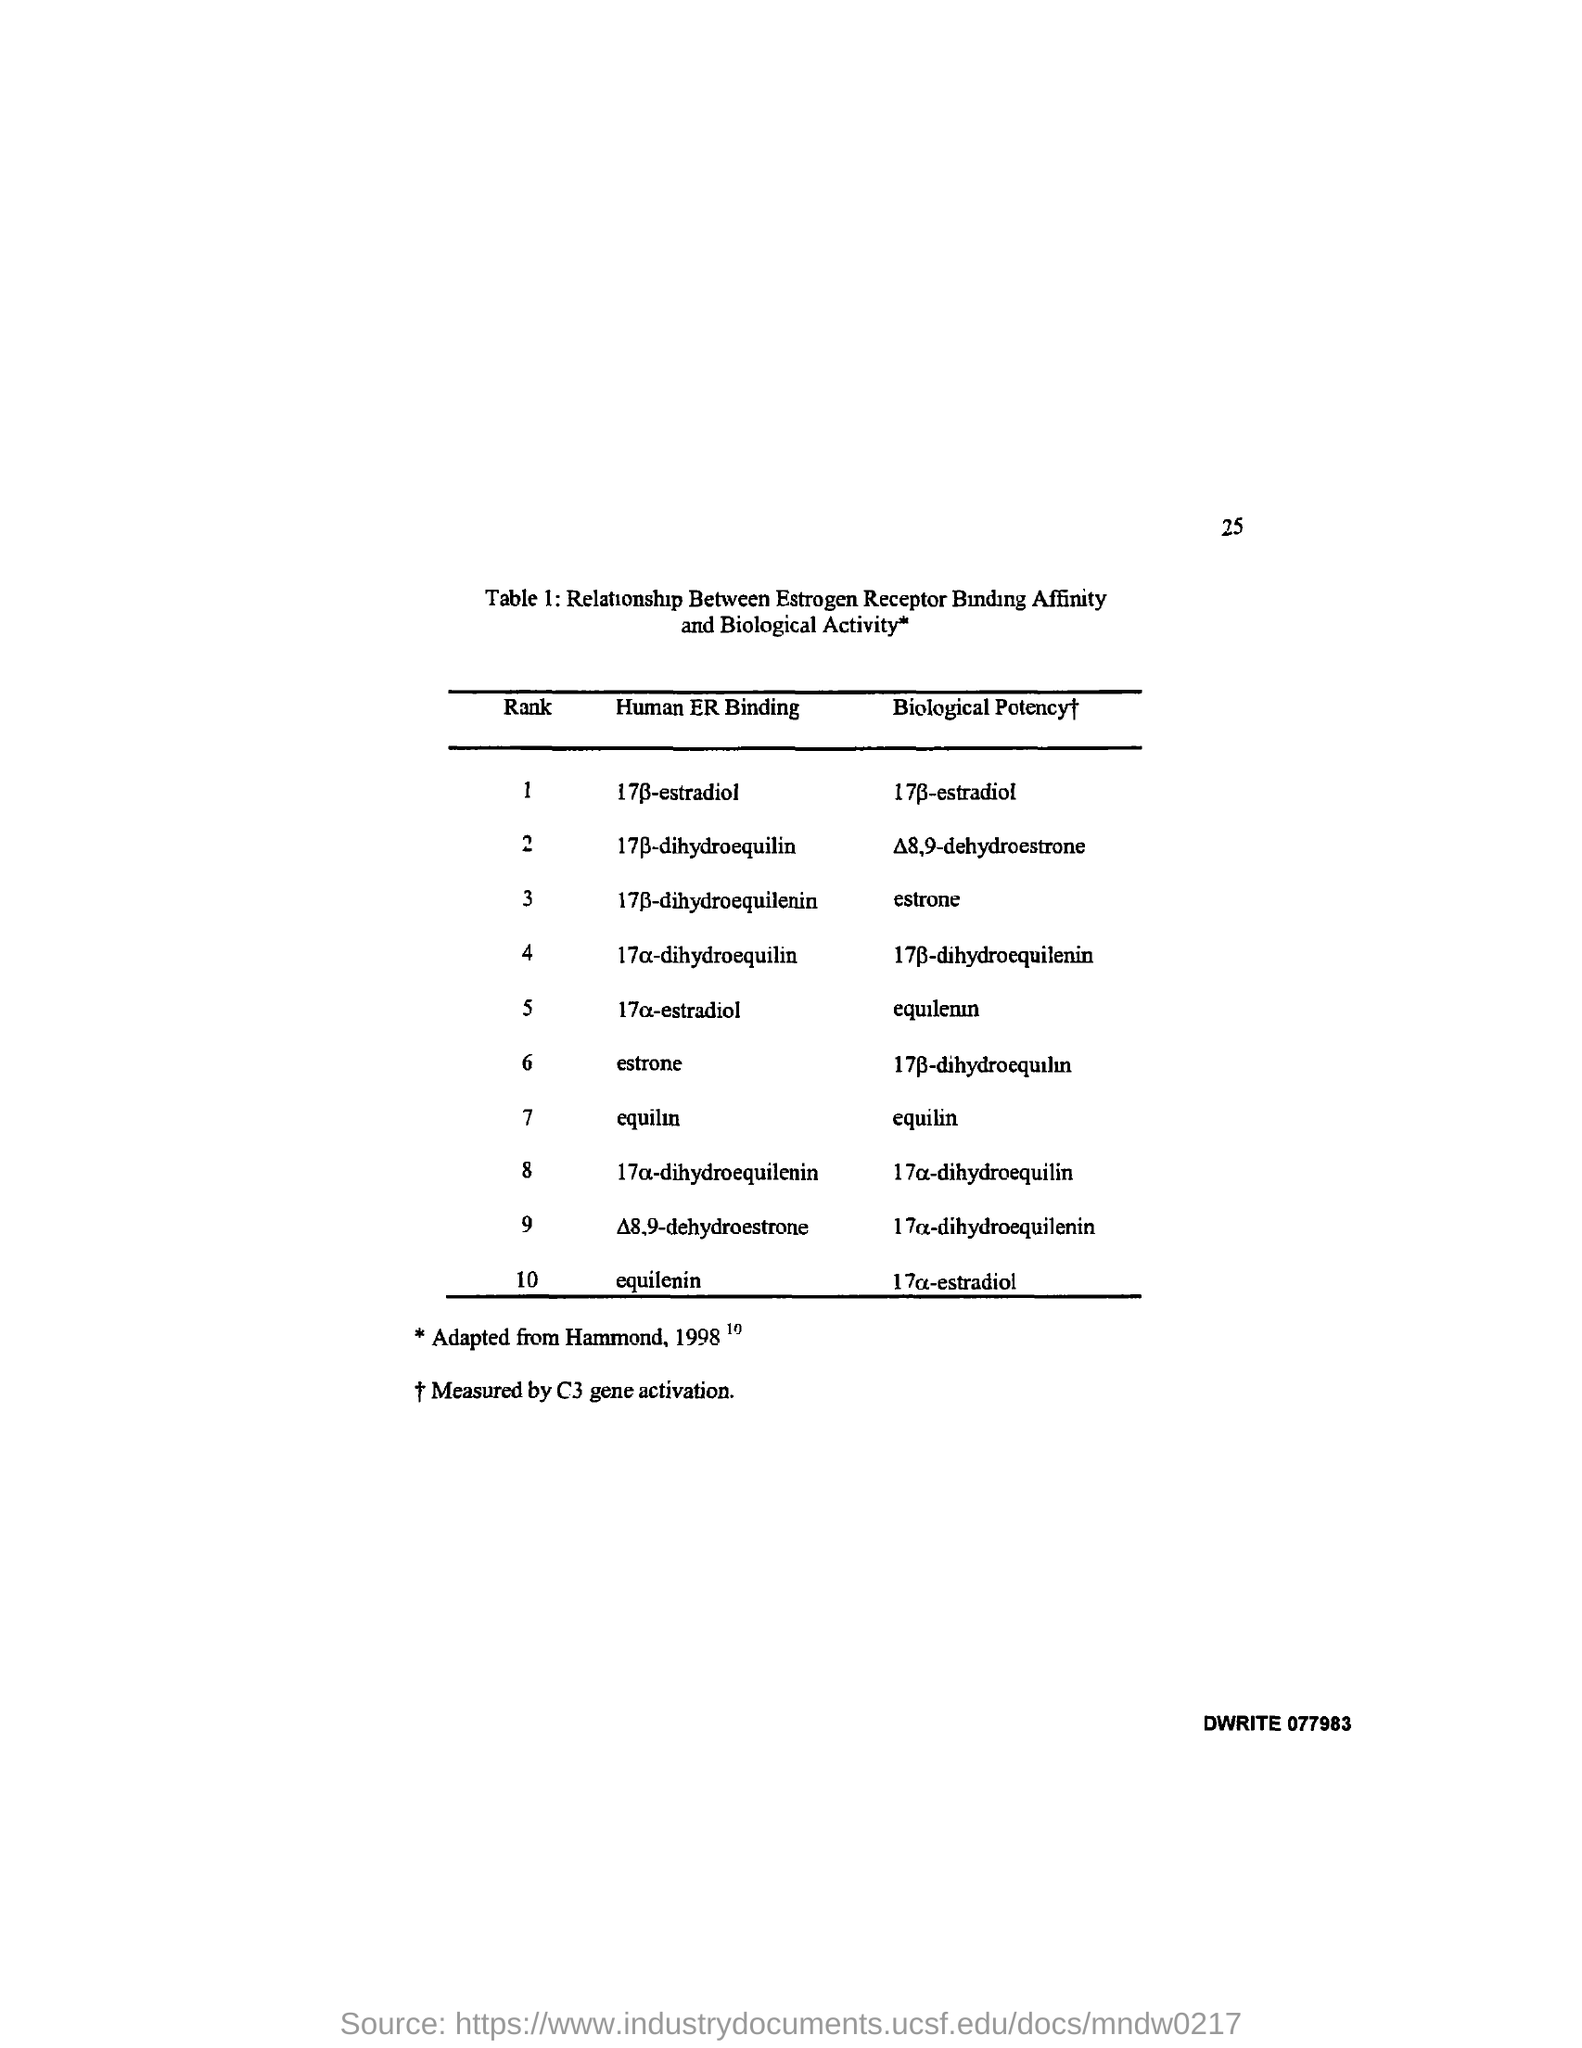What is the page number on this document?
Your response must be concise. 25. Which is the Biological Potency of equilin?
Offer a terse response. Equilin. 